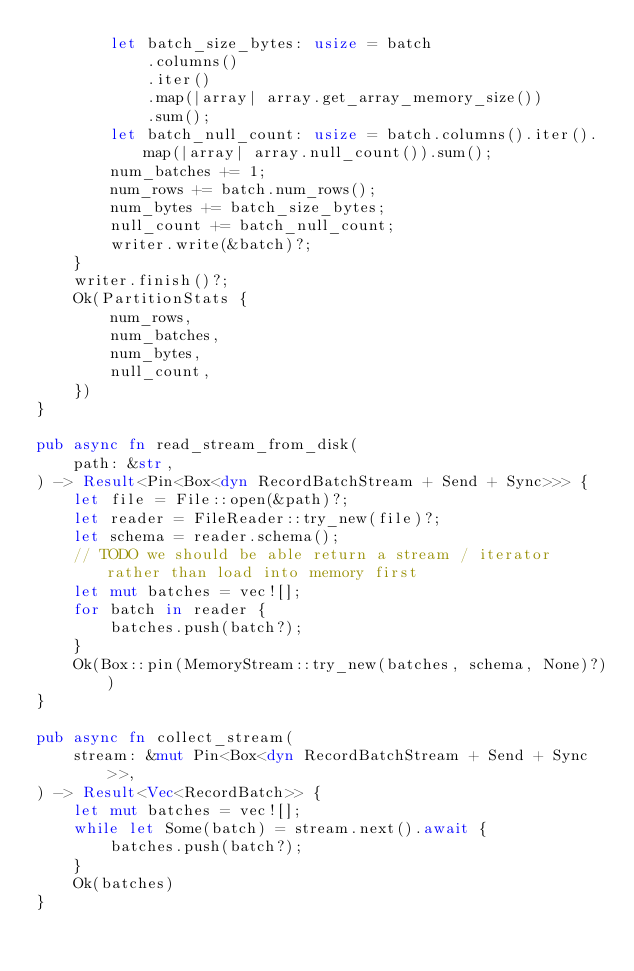<code> <loc_0><loc_0><loc_500><loc_500><_Rust_>        let batch_size_bytes: usize = batch
            .columns()
            .iter()
            .map(|array| array.get_array_memory_size())
            .sum();
        let batch_null_count: usize = batch.columns().iter().map(|array| array.null_count()).sum();
        num_batches += 1;
        num_rows += batch.num_rows();
        num_bytes += batch_size_bytes;
        null_count += batch_null_count;
        writer.write(&batch)?;
    }
    writer.finish()?;
    Ok(PartitionStats {
        num_rows,
        num_batches,
        num_bytes,
        null_count,
    })
}

pub async fn read_stream_from_disk(
    path: &str,
) -> Result<Pin<Box<dyn RecordBatchStream + Send + Sync>>> {
    let file = File::open(&path)?;
    let reader = FileReader::try_new(file)?;
    let schema = reader.schema();
    // TODO we should be able return a stream / iterator rather than load into memory first
    let mut batches = vec![];
    for batch in reader {
        batches.push(batch?);
    }
    Ok(Box::pin(MemoryStream::try_new(batches, schema, None)?))
}

pub async fn collect_stream(
    stream: &mut Pin<Box<dyn RecordBatchStream + Send + Sync>>,
) -> Result<Vec<RecordBatch>> {
    let mut batches = vec![];
    while let Some(batch) = stream.next().await {
        batches.push(batch?);
    }
    Ok(batches)
}
</code> 